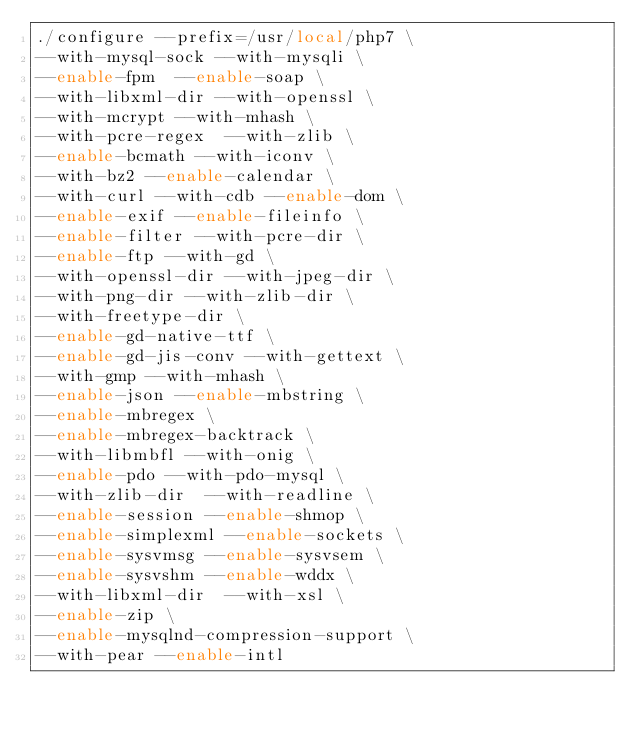Convert code to text. <code><loc_0><loc_0><loc_500><loc_500><_Bash_>./configure --prefix=/usr/local/php7 \
--with-mysql-sock --with-mysqli \
--enable-fpm  --enable-soap \
--with-libxml-dir --with-openssl \
--with-mcrypt --with-mhash \
--with-pcre-regex  --with-zlib \
--enable-bcmath --with-iconv \
--with-bz2 --enable-calendar \
--with-curl --with-cdb --enable-dom \
--enable-exif --enable-fileinfo \
--enable-filter --with-pcre-dir \
--enable-ftp --with-gd \
--with-openssl-dir --with-jpeg-dir \
--with-png-dir --with-zlib-dir \
--with-freetype-dir \
--enable-gd-native-ttf \
--enable-gd-jis-conv --with-gettext \
--with-gmp --with-mhash \
--enable-json --enable-mbstring \
--enable-mbregex \
--enable-mbregex-backtrack \
--with-libmbfl --with-onig \
--enable-pdo --with-pdo-mysql \
--with-zlib-dir  --with-readline \
--enable-session --enable-shmop \
--enable-simplexml --enable-sockets \
--enable-sysvmsg --enable-sysvsem \
--enable-sysvshm --enable-wddx \
--with-libxml-dir  --with-xsl \
--enable-zip \
--enable-mysqlnd-compression-support \
--with-pear --enable-intl
</code> 